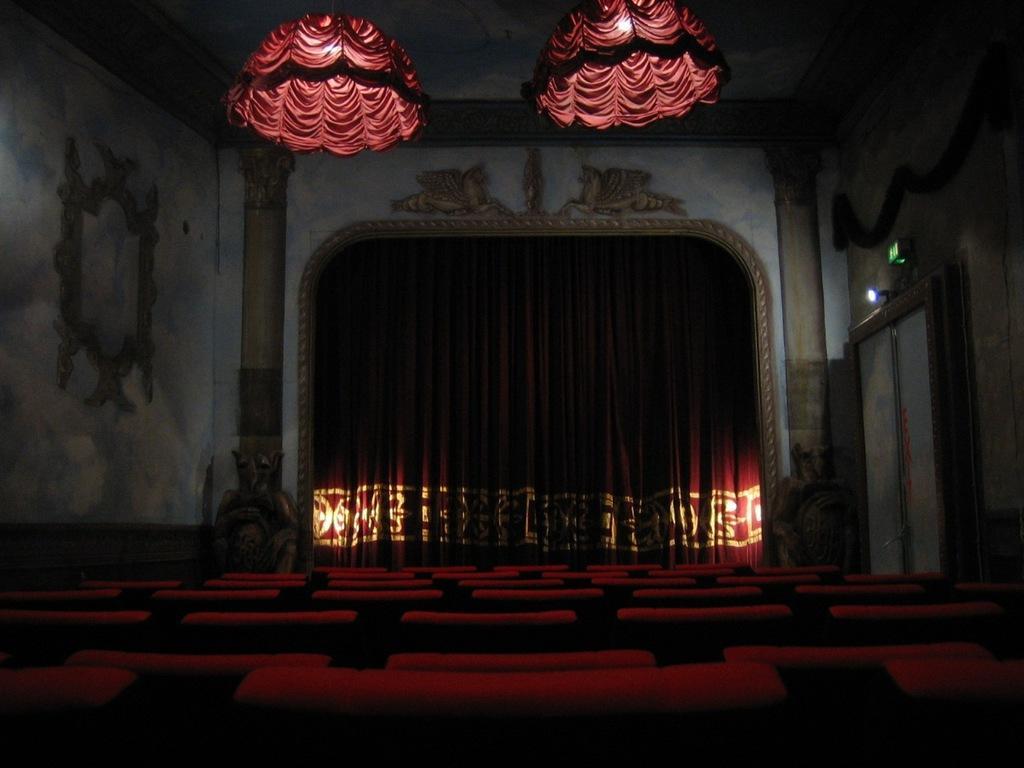Can you describe this image briefly? In this image we can see few chairs, a curtain, wall with design, pillars on both the sides and there are lights covered with clothes on the top and there is a door and a light above the door on the right side. 